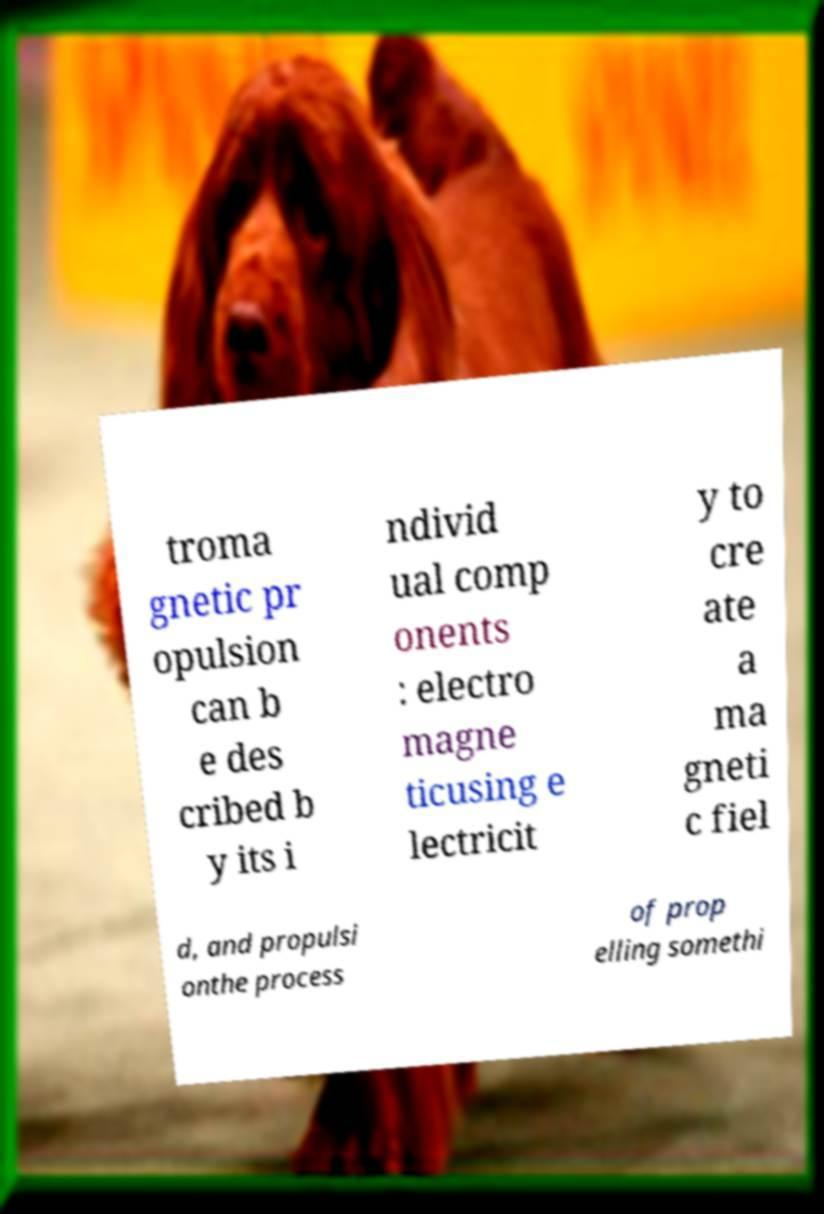There's text embedded in this image that I need extracted. Can you transcribe it verbatim? troma gnetic pr opulsion can b e des cribed b y its i ndivid ual comp onents : electro magne ticusing e lectricit y to cre ate a ma gneti c fiel d, and propulsi onthe process of prop elling somethi 